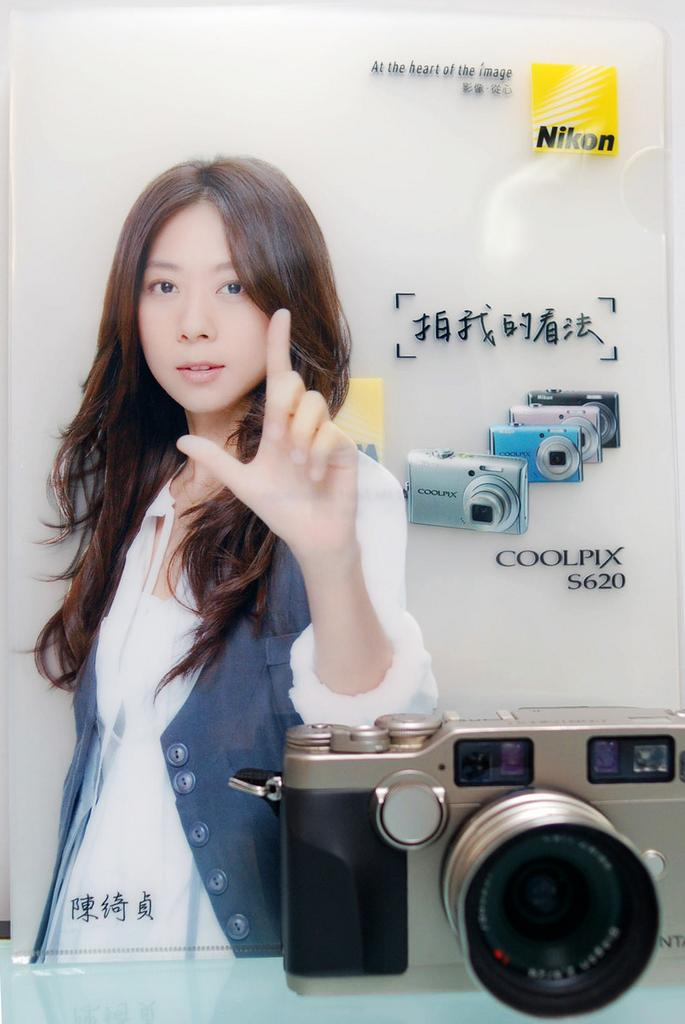What object is placed on the table in the image? There is a camera on a table in the image. What can be seen in the background of the image? There is a poster in the background of the image. What is depicted on the poster? The poster contains images of cameras and features a lady. Is there any text on the poster? Yes, there is text on the poster. What type of toy is being used to create friction on the camera in the image? There is no toy or friction present in the image; the camera is simply placed on the table. 